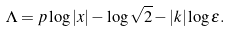<formula> <loc_0><loc_0><loc_500><loc_500>\Lambda = p \log | x | - \log \sqrt { 2 } - | k | \log \epsilon .</formula> 